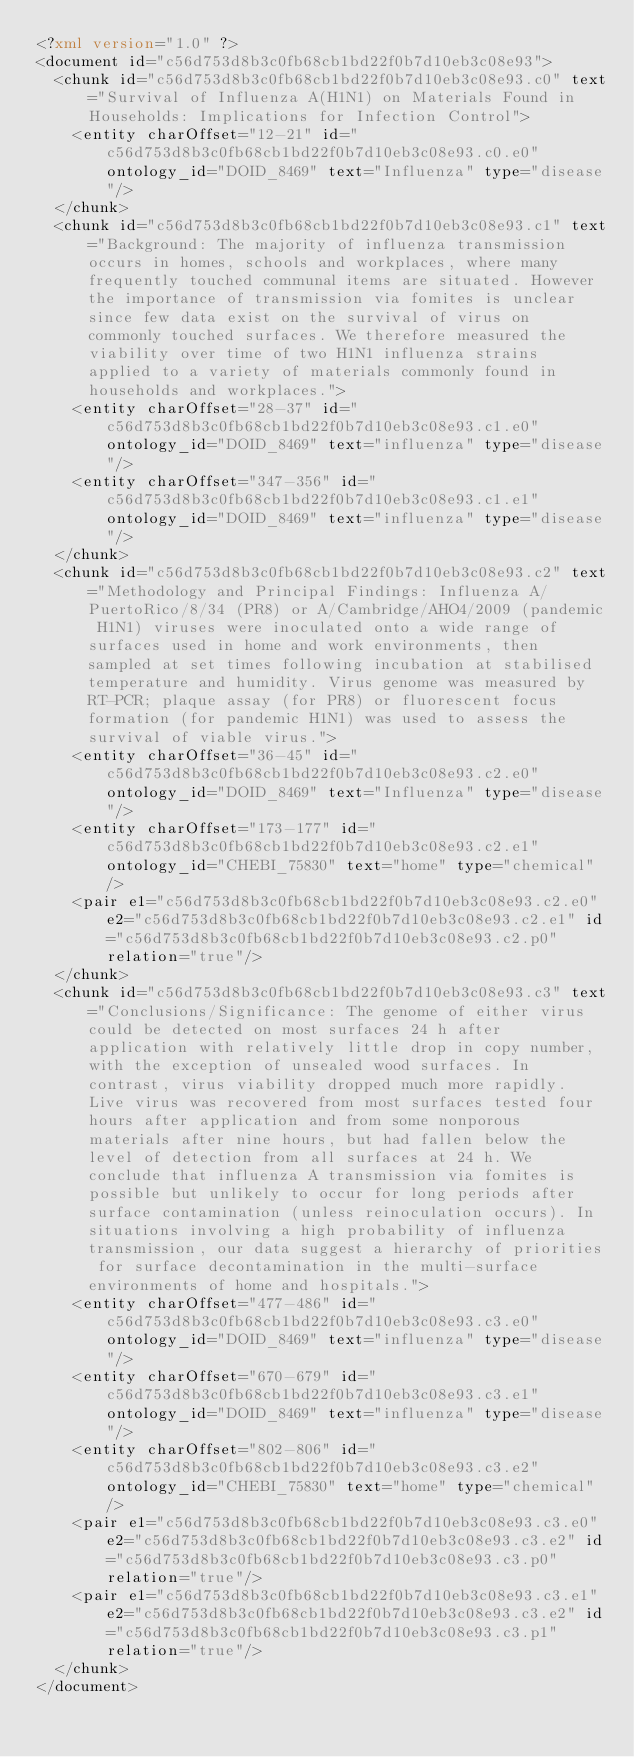<code> <loc_0><loc_0><loc_500><loc_500><_XML_><?xml version="1.0" ?>
<document id="c56d753d8b3c0fb68cb1bd22f0b7d10eb3c08e93">
  <chunk id="c56d753d8b3c0fb68cb1bd22f0b7d10eb3c08e93.c0" text="Survival of Influenza A(H1N1) on Materials Found in Households: Implications for Infection Control">
    <entity charOffset="12-21" id="c56d753d8b3c0fb68cb1bd22f0b7d10eb3c08e93.c0.e0" ontology_id="DOID_8469" text="Influenza" type="disease"/>
  </chunk>
  <chunk id="c56d753d8b3c0fb68cb1bd22f0b7d10eb3c08e93.c1" text="Background: The majority of influenza transmission occurs in homes, schools and workplaces, where many frequently touched communal items are situated. However the importance of transmission via fomites is unclear since few data exist on the survival of virus on commonly touched surfaces. We therefore measured the viability over time of two H1N1 influenza strains applied to a variety of materials commonly found in households and workplaces.">
    <entity charOffset="28-37" id="c56d753d8b3c0fb68cb1bd22f0b7d10eb3c08e93.c1.e0" ontology_id="DOID_8469" text="influenza" type="disease"/>
    <entity charOffset="347-356" id="c56d753d8b3c0fb68cb1bd22f0b7d10eb3c08e93.c1.e1" ontology_id="DOID_8469" text="influenza" type="disease"/>
  </chunk>
  <chunk id="c56d753d8b3c0fb68cb1bd22f0b7d10eb3c08e93.c2" text="Methodology and Principal Findings: Influenza A/PuertoRico/8/34 (PR8) or A/Cambridge/AHO4/2009 (pandemic H1N1) viruses were inoculated onto a wide range of surfaces used in home and work environments, then sampled at set times following incubation at stabilised temperature and humidity. Virus genome was measured by RT-PCR; plaque assay (for PR8) or fluorescent focus formation (for pandemic H1N1) was used to assess the survival of viable virus.">
    <entity charOffset="36-45" id="c56d753d8b3c0fb68cb1bd22f0b7d10eb3c08e93.c2.e0" ontology_id="DOID_8469" text="Influenza" type="disease"/>
    <entity charOffset="173-177" id="c56d753d8b3c0fb68cb1bd22f0b7d10eb3c08e93.c2.e1" ontology_id="CHEBI_75830" text="home" type="chemical"/>
    <pair e1="c56d753d8b3c0fb68cb1bd22f0b7d10eb3c08e93.c2.e0" e2="c56d753d8b3c0fb68cb1bd22f0b7d10eb3c08e93.c2.e1" id="c56d753d8b3c0fb68cb1bd22f0b7d10eb3c08e93.c2.p0" relation="true"/>
  </chunk>
  <chunk id="c56d753d8b3c0fb68cb1bd22f0b7d10eb3c08e93.c3" text="Conclusions/Significance: The genome of either virus could be detected on most surfaces 24 h after application with relatively little drop in copy number, with the exception of unsealed wood surfaces. In contrast, virus viability dropped much more rapidly. Live virus was recovered from most surfaces tested four hours after application and from some nonporous materials after nine hours, but had fallen below the level of detection from all surfaces at 24 h. We conclude that influenza A transmission via fomites is possible but unlikely to occur for long periods after surface contamination (unless reinoculation occurs). In situations involving a high probability of influenza transmission, our data suggest a hierarchy of priorities for surface decontamination in the multi-surface environments of home and hospitals.">
    <entity charOffset="477-486" id="c56d753d8b3c0fb68cb1bd22f0b7d10eb3c08e93.c3.e0" ontology_id="DOID_8469" text="influenza" type="disease"/>
    <entity charOffset="670-679" id="c56d753d8b3c0fb68cb1bd22f0b7d10eb3c08e93.c3.e1" ontology_id="DOID_8469" text="influenza" type="disease"/>
    <entity charOffset="802-806" id="c56d753d8b3c0fb68cb1bd22f0b7d10eb3c08e93.c3.e2" ontology_id="CHEBI_75830" text="home" type="chemical"/>
    <pair e1="c56d753d8b3c0fb68cb1bd22f0b7d10eb3c08e93.c3.e0" e2="c56d753d8b3c0fb68cb1bd22f0b7d10eb3c08e93.c3.e2" id="c56d753d8b3c0fb68cb1bd22f0b7d10eb3c08e93.c3.p0" relation="true"/>
    <pair e1="c56d753d8b3c0fb68cb1bd22f0b7d10eb3c08e93.c3.e1" e2="c56d753d8b3c0fb68cb1bd22f0b7d10eb3c08e93.c3.e2" id="c56d753d8b3c0fb68cb1bd22f0b7d10eb3c08e93.c3.p1" relation="true"/>
  </chunk>
</document>
</code> 